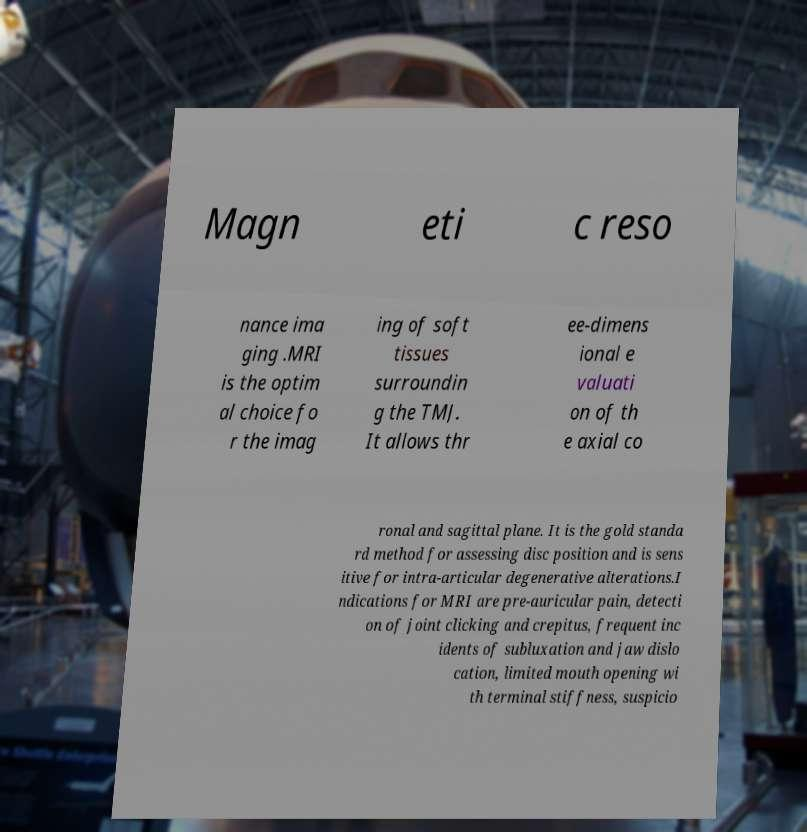What messages or text are displayed in this image? I need them in a readable, typed format. Magn eti c reso nance ima ging .MRI is the optim al choice fo r the imag ing of soft tissues surroundin g the TMJ. It allows thr ee-dimens ional e valuati on of th e axial co ronal and sagittal plane. It is the gold standa rd method for assessing disc position and is sens itive for intra-articular degenerative alterations.I ndications for MRI are pre-auricular pain, detecti on of joint clicking and crepitus, frequent inc idents of subluxation and jaw dislo cation, limited mouth opening wi th terminal stiffness, suspicio 